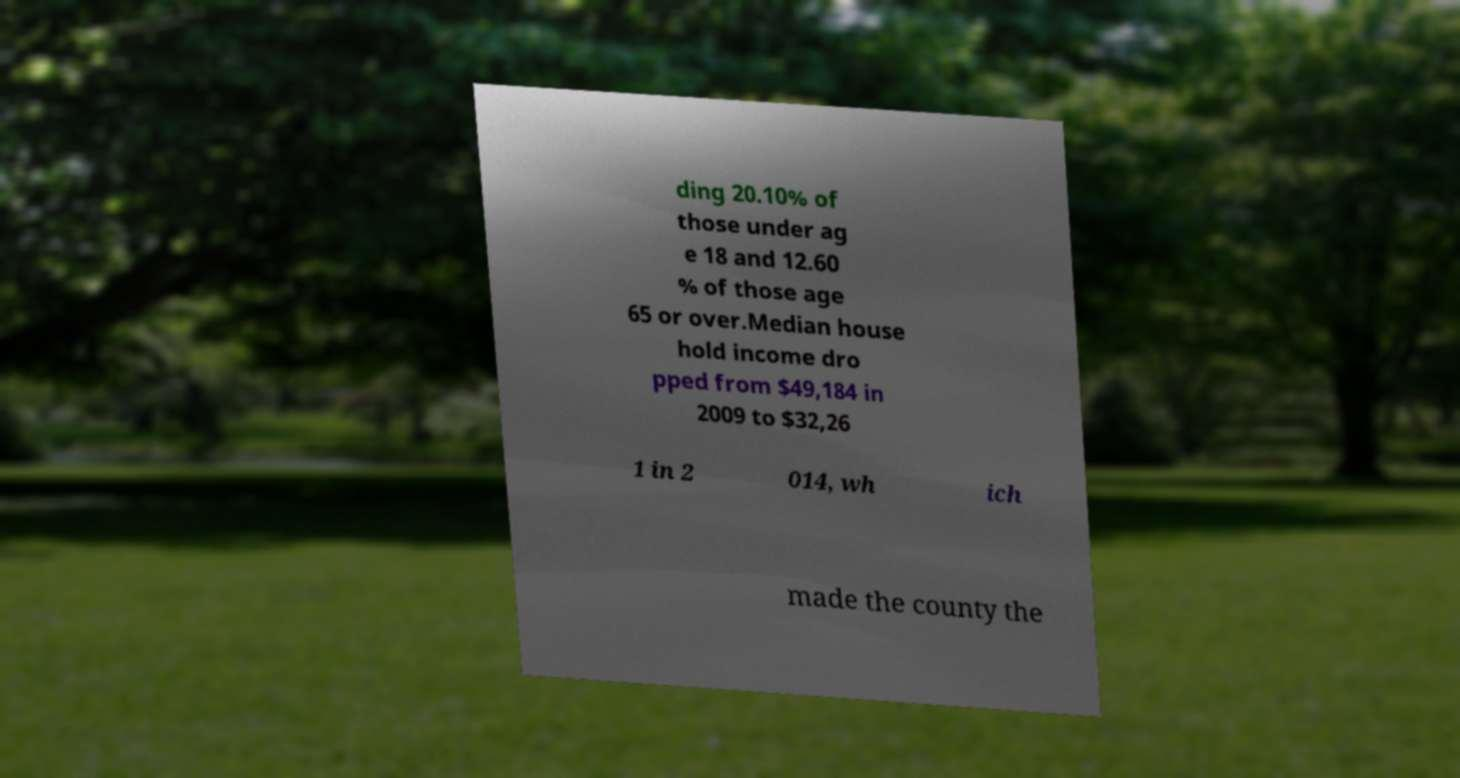Can you read and provide the text displayed in the image?This photo seems to have some interesting text. Can you extract and type it out for me? ding 20.10% of those under ag e 18 and 12.60 % of those age 65 or over.Median house hold income dro pped from $49,184 in 2009 to $32,26 1 in 2 014, wh ich made the county the 